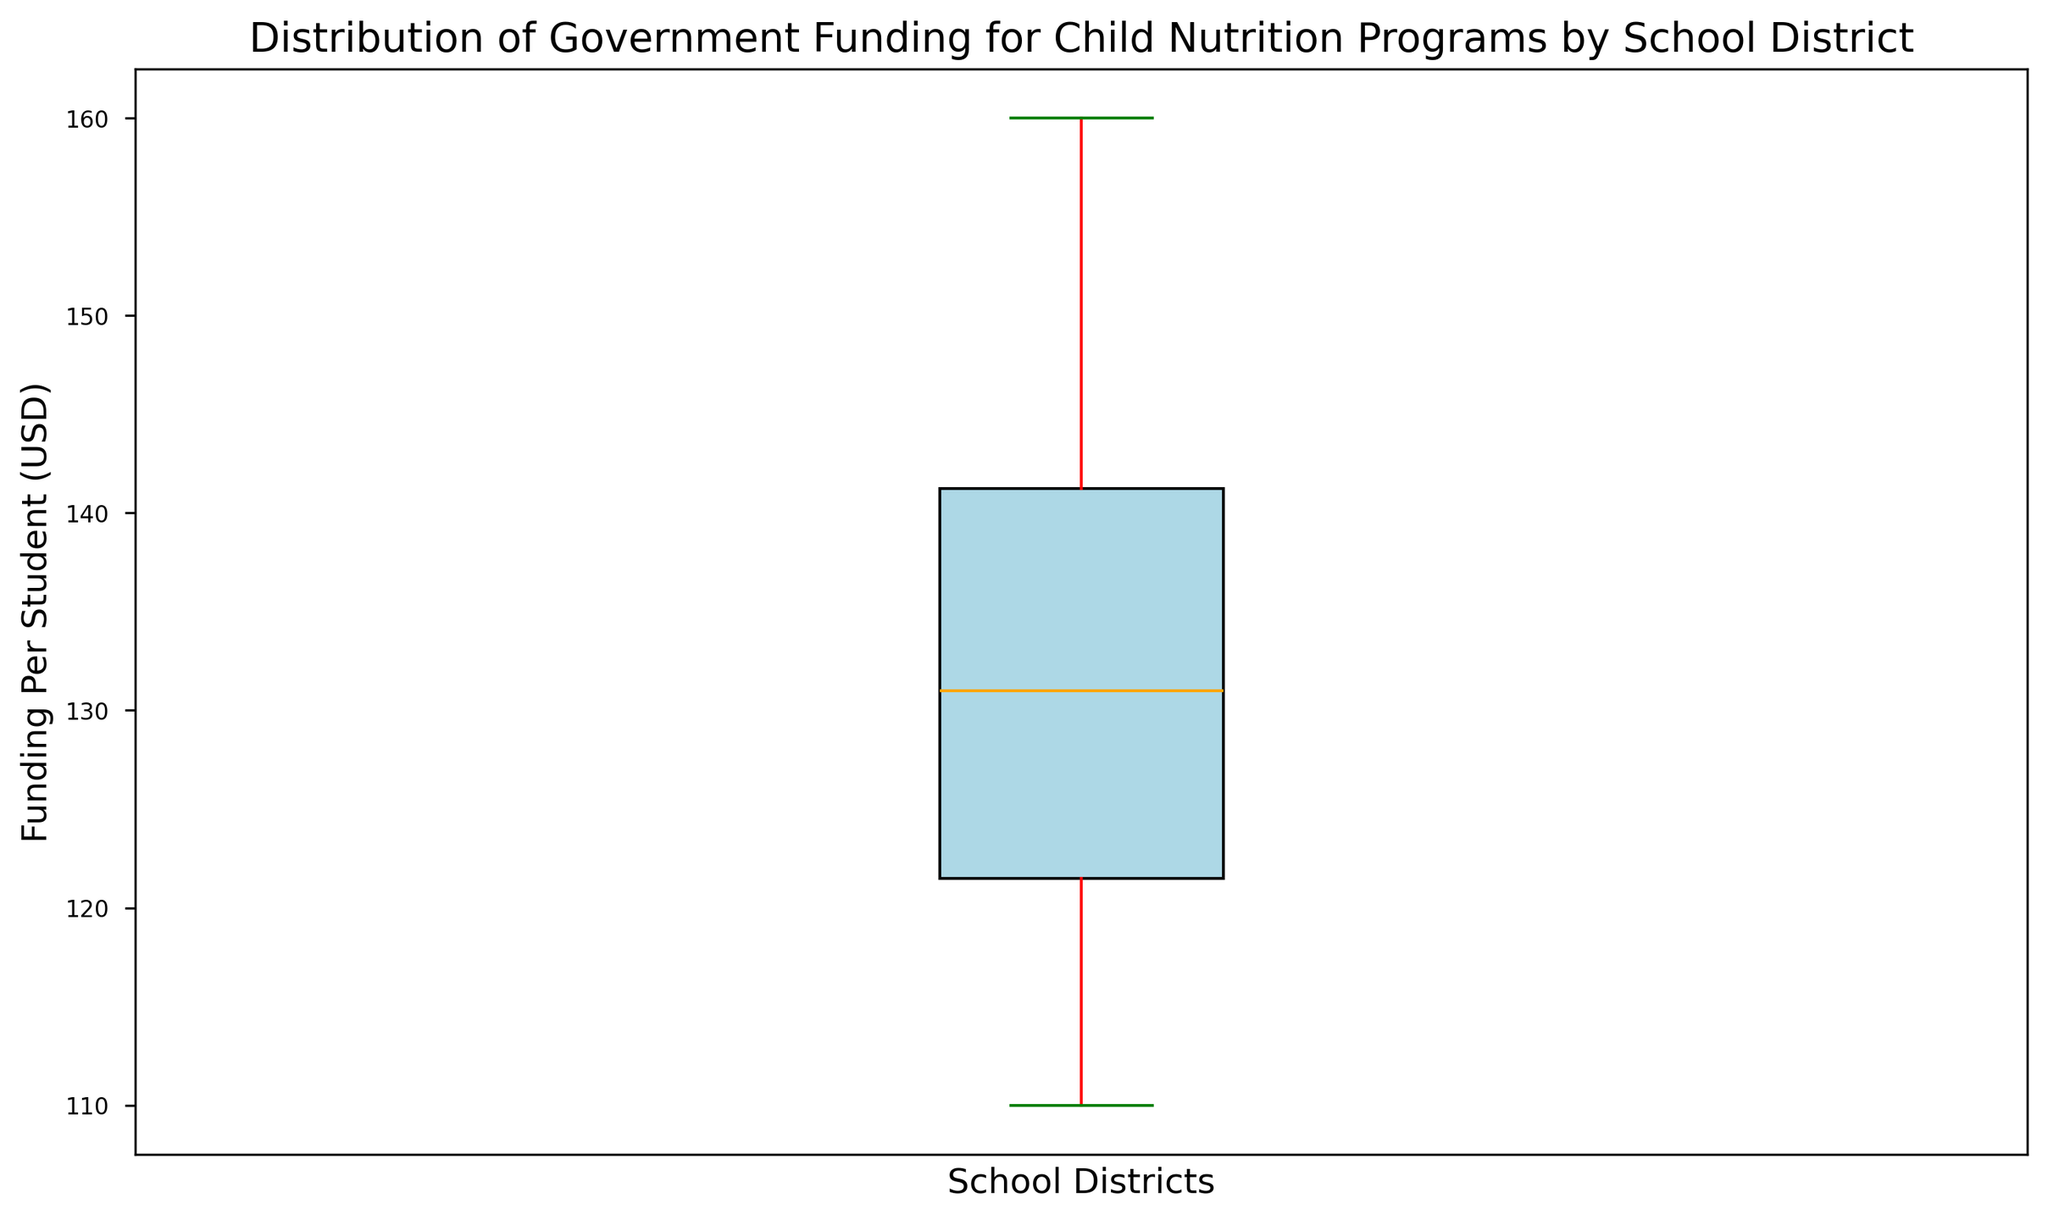What is the median level of funding per student across the school districts? The median is represented by the orange line within the box in the box plot. Look at the position of this line on the y-axis which measures funding per student.
Answer: 132.5 What is the range of the funding per student across the school districts? The range is found by subtracting the minimum funding value (bottom whisker) from the maximum funding value (top whisker). The y-axis indicates these points.
Answer: 50 Are there any outliers in the distribution of funding per student? Outliers would be indicated by points that fall beyond the whiskers of the box plot, typically shown as individual dots or stars. Check the figure for such markers.
Answer: No Considering both the whiskers, what is the interquartile range (IQR) of the funding? The interquartile range (IQR) is the difference between the third quartile (top of the box) and the first quartile (bottom of the box). Identify these points from the box plot on the y-axis and subtract them.
Answer: 21.75 Is the distribution of funding per student positively skewed, negatively skewed, or symmetric? Examine the lengths of the whiskers and the central position of the median. If the upper whisker is much longer, the distribution is positively skewed; if the lower whisker is longer, it’s negatively skewed; if they are roughly equal, the distribution is symmetric.
Answer: Positively skewed What is the maximum funding per student observed in the school districts? The maximum funding is represented by the top of the upper whisker visible on the y-axis.
Answer: 160 What is the minimum funding per student observed in the school districts? The minimum funding is represented by the bottom of the lower whisker visible on the y-axis.
Answer: 110 What is the difference between the median and the first quartile of the funding? Identify the median value (orange line) and the first quartile (bottom of the box). Subtract the first quartile value from the median value.
Answer: 11.75 